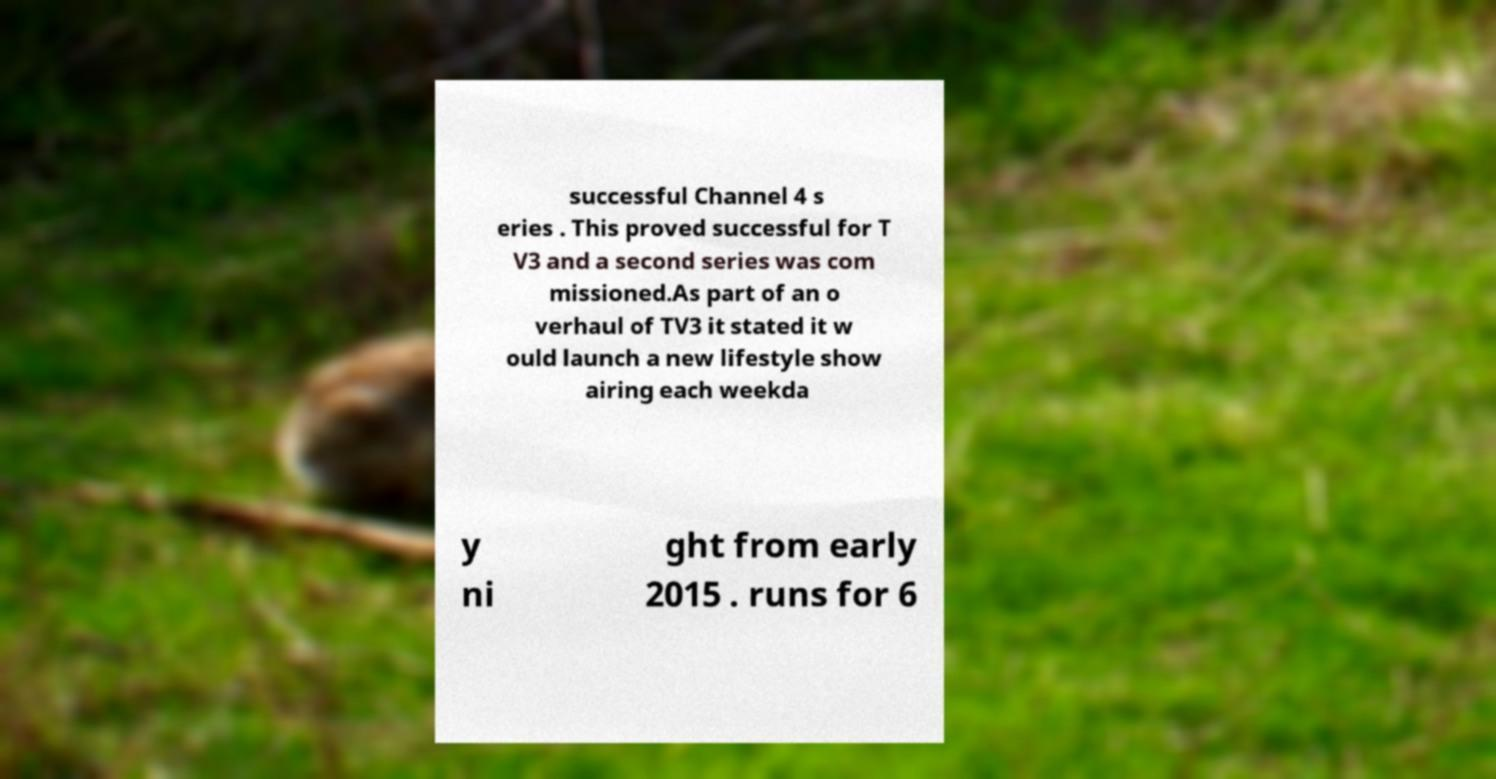For documentation purposes, I need the text within this image transcribed. Could you provide that? successful Channel 4 s eries . This proved successful for T V3 and a second series was com missioned.As part of an o verhaul of TV3 it stated it w ould launch a new lifestyle show airing each weekda y ni ght from early 2015 . runs for 6 